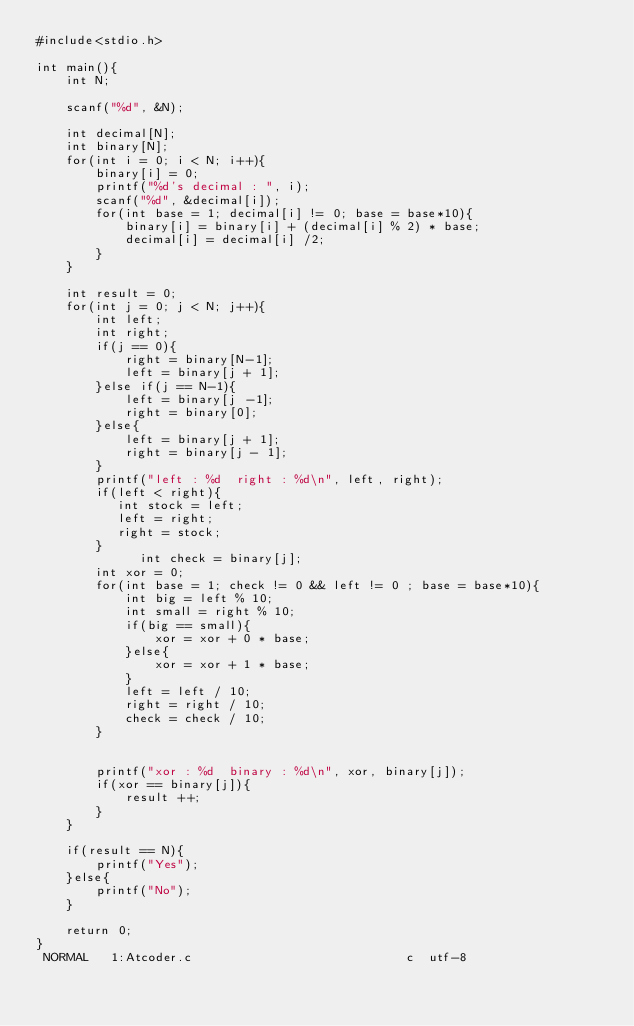<code> <loc_0><loc_0><loc_500><loc_500><_C_>#include<stdio.h>

int main(){
    int N;

    scanf("%d", &N);

    int decimal[N];
    int binary[N];
    for(int i = 0; i < N; i++){
        binary[i] = 0;
        printf("%d's decimal : ", i);
        scanf("%d", &decimal[i]);
        for(int base = 1; decimal[i] != 0; base = base*10){
            binary[i] = binary[i] + (decimal[i] % 2) * base;
            decimal[i] = decimal[i] /2;
        }
    }

    int result = 0;
    for(int j = 0; j < N; j++){
        int left;
        int right;
        if(j == 0){                                                                                  
            right = binary[N-1];                                                                     
            left = binary[j + 1];                                                                    
        }else if(j == N-1){                                                                          
            left = binary[j -1];                                                                     
            right = binary[0];                                                                       
        }else{                                                                                       
            left = binary[j + 1];                                                                    
            right = binary[j - 1];                                                                   
        }                                                                                            
        printf("left : %d  right : %d\n", left, right);                                              
        if(left < right){                                                                            
           int stock = left;                                                                         
           left = right;                                                                             
           right = stock;                                                                            
        }  
              int check = binary[j];                                                                       
        int xor = 0;                                                                                 
        for(int base = 1; check != 0 && left != 0 ; base = base*10){                                 
            int big = left % 10;                                                                     
            int small = right % 10;                                                                  
            if(big == small){                                                                        
                xor = xor + 0 * base;                                                                
            }else{
                xor = xor + 1 * base;
            }
            left = left / 10;
            right = right / 10;
            check = check / 10;
        }


        printf("xor : %d  binary : %d\n", xor, binary[j]);
        if(xor == binary[j]){
            result ++;
        }
    }

    if(result == N){
        printf("Yes");
    }else{
        printf("No");
    }

    return 0;
}
 NORMAL   1:Atcoder.c                             c  utf-8</code> 